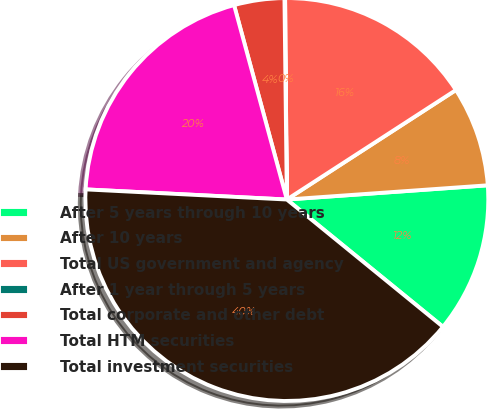<chart> <loc_0><loc_0><loc_500><loc_500><pie_chart><fcel>After 5 years through 10 years<fcel>After 10 years<fcel>Total US government and agency<fcel>After 1 year through 5 years<fcel>Total corporate and other debt<fcel>Total HTM securities<fcel>Total investment securities<nl><fcel>12.01%<fcel>8.02%<fcel>15.99%<fcel>0.05%<fcel>4.03%<fcel>19.98%<fcel>39.91%<nl></chart> 